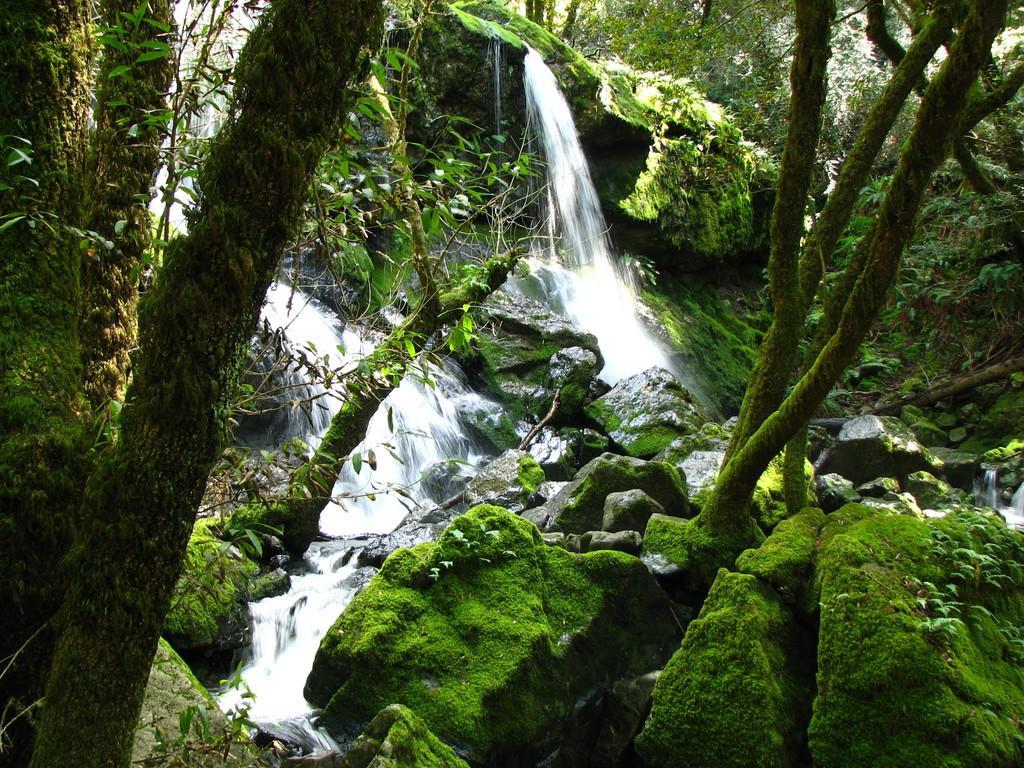Can you describe this image briefly? In this image I can see trees in green color. Background I can see few stones and waterfall. 